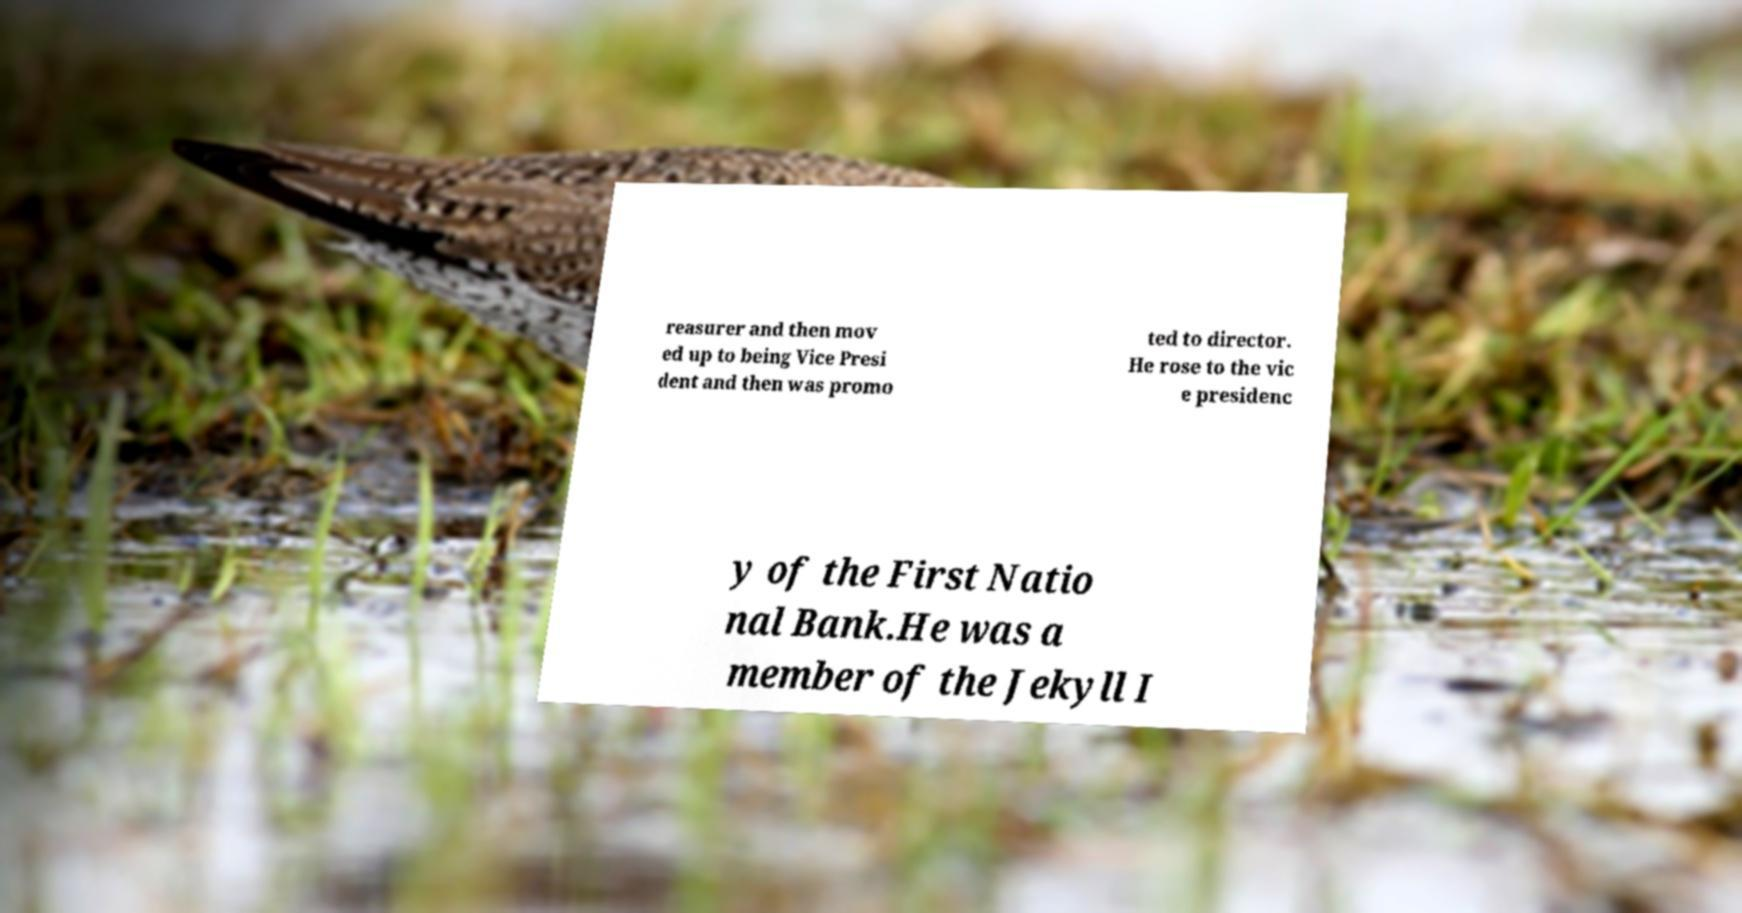There's text embedded in this image that I need extracted. Can you transcribe it verbatim? reasurer and then mov ed up to being Vice Presi dent and then was promo ted to director. He rose to the vic e presidenc y of the First Natio nal Bank.He was a member of the Jekyll I 